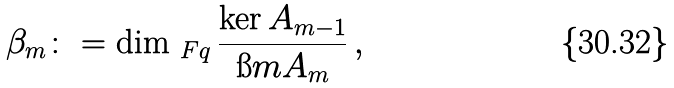<formula> <loc_0><loc_0><loc_500><loc_500>\beta _ { m } \colon = \dim _ { \ F q } \frac { \ker A _ { m - 1 } } { \i m A _ { m } } \, ,</formula> 